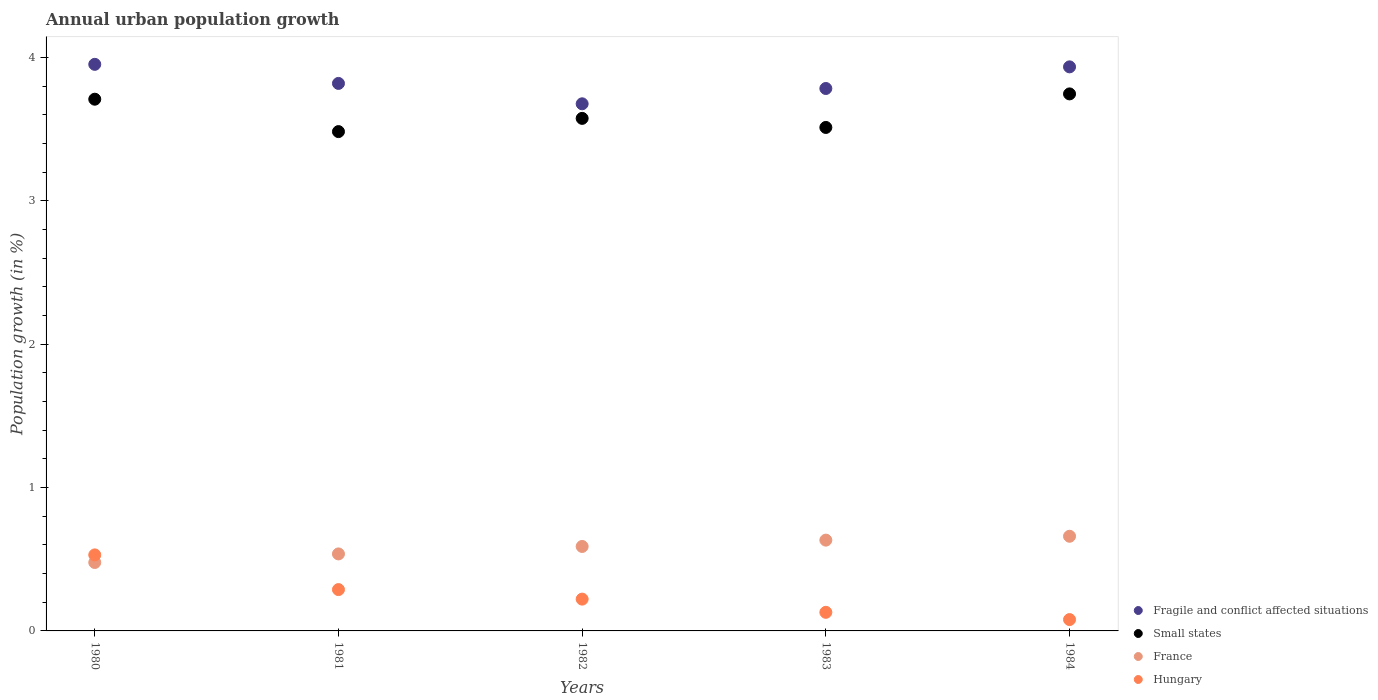How many different coloured dotlines are there?
Provide a short and direct response. 4. Is the number of dotlines equal to the number of legend labels?
Make the answer very short. Yes. What is the percentage of urban population growth in France in 1984?
Offer a terse response. 0.66. Across all years, what is the maximum percentage of urban population growth in Hungary?
Keep it short and to the point. 0.53. Across all years, what is the minimum percentage of urban population growth in Hungary?
Offer a very short reply. 0.08. In which year was the percentage of urban population growth in Hungary minimum?
Your response must be concise. 1984. What is the total percentage of urban population growth in Hungary in the graph?
Offer a very short reply. 1.25. What is the difference between the percentage of urban population growth in Fragile and conflict affected situations in 1981 and that in 1983?
Your answer should be very brief. 0.04. What is the difference between the percentage of urban population growth in France in 1984 and the percentage of urban population growth in Small states in 1982?
Make the answer very short. -2.92. What is the average percentage of urban population growth in Hungary per year?
Your response must be concise. 0.25. In the year 1981, what is the difference between the percentage of urban population growth in France and percentage of urban population growth in Small states?
Give a very brief answer. -2.95. What is the ratio of the percentage of urban population growth in Small states in 1980 to that in 1983?
Keep it short and to the point. 1.06. Is the difference between the percentage of urban population growth in France in 1980 and 1983 greater than the difference between the percentage of urban population growth in Small states in 1980 and 1983?
Your response must be concise. No. What is the difference between the highest and the second highest percentage of urban population growth in Small states?
Ensure brevity in your answer.  0.04. What is the difference between the highest and the lowest percentage of urban population growth in Fragile and conflict affected situations?
Give a very brief answer. 0.28. In how many years, is the percentage of urban population growth in France greater than the average percentage of urban population growth in France taken over all years?
Provide a succinct answer. 3. Is the sum of the percentage of urban population growth in Fragile and conflict affected situations in 1980 and 1984 greater than the maximum percentage of urban population growth in Small states across all years?
Your answer should be very brief. Yes. Does the percentage of urban population growth in France monotonically increase over the years?
Offer a very short reply. Yes. Is the percentage of urban population growth in Fragile and conflict affected situations strictly less than the percentage of urban population growth in France over the years?
Provide a succinct answer. No. How many dotlines are there?
Your response must be concise. 4. How many years are there in the graph?
Keep it short and to the point. 5. What is the difference between two consecutive major ticks on the Y-axis?
Offer a terse response. 1. Does the graph contain any zero values?
Your answer should be compact. No. How many legend labels are there?
Ensure brevity in your answer.  4. What is the title of the graph?
Ensure brevity in your answer.  Annual urban population growth. Does "Lower middle income" appear as one of the legend labels in the graph?
Keep it short and to the point. No. What is the label or title of the X-axis?
Offer a very short reply. Years. What is the label or title of the Y-axis?
Give a very brief answer. Population growth (in %). What is the Population growth (in %) of Fragile and conflict affected situations in 1980?
Provide a succinct answer. 3.95. What is the Population growth (in %) in Small states in 1980?
Your answer should be compact. 3.71. What is the Population growth (in %) in France in 1980?
Provide a short and direct response. 0.48. What is the Population growth (in %) in Hungary in 1980?
Your response must be concise. 0.53. What is the Population growth (in %) in Fragile and conflict affected situations in 1981?
Offer a very short reply. 3.82. What is the Population growth (in %) in Small states in 1981?
Offer a very short reply. 3.48. What is the Population growth (in %) of France in 1981?
Give a very brief answer. 0.54. What is the Population growth (in %) in Hungary in 1981?
Make the answer very short. 0.29. What is the Population growth (in %) in Fragile and conflict affected situations in 1982?
Keep it short and to the point. 3.68. What is the Population growth (in %) of Small states in 1982?
Your answer should be very brief. 3.58. What is the Population growth (in %) in France in 1982?
Offer a very short reply. 0.59. What is the Population growth (in %) of Hungary in 1982?
Offer a terse response. 0.22. What is the Population growth (in %) in Fragile and conflict affected situations in 1983?
Make the answer very short. 3.78. What is the Population growth (in %) of Small states in 1983?
Provide a short and direct response. 3.51. What is the Population growth (in %) of France in 1983?
Make the answer very short. 0.63. What is the Population growth (in %) in Hungary in 1983?
Provide a succinct answer. 0.13. What is the Population growth (in %) of Fragile and conflict affected situations in 1984?
Offer a terse response. 3.94. What is the Population growth (in %) of Small states in 1984?
Your response must be concise. 3.75. What is the Population growth (in %) in France in 1984?
Offer a very short reply. 0.66. What is the Population growth (in %) in Hungary in 1984?
Your answer should be very brief. 0.08. Across all years, what is the maximum Population growth (in %) in Fragile and conflict affected situations?
Your answer should be very brief. 3.95. Across all years, what is the maximum Population growth (in %) of Small states?
Your answer should be compact. 3.75. Across all years, what is the maximum Population growth (in %) in France?
Provide a short and direct response. 0.66. Across all years, what is the maximum Population growth (in %) in Hungary?
Provide a succinct answer. 0.53. Across all years, what is the minimum Population growth (in %) in Fragile and conflict affected situations?
Your answer should be compact. 3.68. Across all years, what is the minimum Population growth (in %) of Small states?
Offer a terse response. 3.48. Across all years, what is the minimum Population growth (in %) of France?
Ensure brevity in your answer.  0.48. Across all years, what is the minimum Population growth (in %) in Hungary?
Provide a succinct answer. 0.08. What is the total Population growth (in %) in Fragile and conflict affected situations in the graph?
Your answer should be very brief. 19.17. What is the total Population growth (in %) of Small states in the graph?
Offer a very short reply. 18.03. What is the total Population growth (in %) of France in the graph?
Offer a terse response. 2.9. What is the total Population growth (in %) of Hungary in the graph?
Your answer should be very brief. 1.25. What is the difference between the Population growth (in %) in Fragile and conflict affected situations in 1980 and that in 1981?
Ensure brevity in your answer.  0.13. What is the difference between the Population growth (in %) in Small states in 1980 and that in 1981?
Offer a terse response. 0.23. What is the difference between the Population growth (in %) of France in 1980 and that in 1981?
Provide a succinct answer. -0.06. What is the difference between the Population growth (in %) in Hungary in 1980 and that in 1981?
Your answer should be compact. 0.24. What is the difference between the Population growth (in %) of Fragile and conflict affected situations in 1980 and that in 1982?
Offer a terse response. 0.28. What is the difference between the Population growth (in %) in Small states in 1980 and that in 1982?
Ensure brevity in your answer.  0.13. What is the difference between the Population growth (in %) in France in 1980 and that in 1982?
Your response must be concise. -0.11. What is the difference between the Population growth (in %) in Hungary in 1980 and that in 1982?
Your answer should be very brief. 0.31. What is the difference between the Population growth (in %) in Fragile and conflict affected situations in 1980 and that in 1983?
Offer a very short reply. 0.17. What is the difference between the Population growth (in %) of Small states in 1980 and that in 1983?
Your answer should be compact. 0.2. What is the difference between the Population growth (in %) of France in 1980 and that in 1983?
Ensure brevity in your answer.  -0.16. What is the difference between the Population growth (in %) in Hungary in 1980 and that in 1983?
Offer a very short reply. 0.4. What is the difference between the Population growth (in %) in Fragile and conflict affected situations in 1980 and that in 1984?
Provide a succinct answer. 0.02. What is the difference between the Population growth (in %) in Small states in 1980 and that in 1984?
Provide a succinct answer. -0.04. What is the difference between the Population growth (in %) in France in 1980 and that in 1984?
Your answer should be compact. -0.18. What is the difference between the Population growth (in %) in Hungary in 1980 and that in 1984?
Offer a very short reply. 0.45. What is the difference between the Population growth (in %) in Fragile and conflict affected situations in 1981 and that in 1982?
Your answer should be compact. 0.14. What is the difference between the Population growth (in %) of Small states in 1981 and that in 1982?
Your response must be concise. -0.09. What is the difference between the Population growth (in %) of France in 1981 and that in 1982?
Make the answer very short. -0.05. What is the difference between the Population growth (in %) in Hungary in 1981 and that in 1982?
Make the answer very short. 0.07. What is the difference between the Population growth (in %) of Fragile and conflict affected situations in 1981 and that in 1983?
Provide a succinct answer. 0.04. What is the difference between the Population growth (in %) of Small states in 1981 and that in 1983?
Offer a terse response. -0.03. What is the difference between the Population growth (in %) in France in 1981 and that in 1983?
Your response must be concise. -0.1. What is the difference between the Population growth (in %) of Hungary in 1981 and that in 1983?
Ensure brevity in your answer.  0.16. What is the difference between the Population growth (in %) in Fragile and conflict affected situations in 1981 and that in 1984?
Make the answer very short. -0.12. What is the difference between the Population growth (in %) of Small states in 1981 and that in 1984?
Offer a terse response. -0.26. What is the difference between the Population growth (in %) of France in 1981 and that in 1984?
Give a very brief answer. -0.12. What is the difference between the Population growth (in %) of Hungary in 1981 and that in 1984?
Keep it short and to the point. 0.21. What is the difference between the Population growth (in %) in Fragile and conflict affected situations in 1982 and that in 1983?
Give a very brief answer. -0.11. What is the difference between the Population growth (in %) in Small states in 1982 and that in 1983?
Ensure brevity in your answer.  0.06. What is the difference between the Population growth (in %) in France in 1982 and that in 1983?
Your answer should be very brief. -0.04. What is the difference between the Population growth (in %) in Hungary in 1982 and that in 1983?
Ensure brevity in your answer.  0.09. What is the difference between the Population growth (in %) of Fragile and conflict affected situations in 1982 and that in 1984?
Make the answer very short. -0.26. What is the difference between the Population growth (in %) of Small states in 1982 and that in 1984?
Your answer should be compact. -0.17. What is the difference between the Population growth (in %) in France in 1982 and that in 1984?
Make the answer very short. -0.07. What is the difference between the Population growth (in %) in Hungary in 1982 and that in 1984?
Your answer should be compact. 0.14. What is the difference between the Population growth (in %) of Fragile and conflict affected situations in 1983 and that in 1984?
Ensure brevity in your answer.  -0.15. What is the difference between the Population growth (in %) of Small states in 1983 and that in 1984?
Your answer should be very brief. -0.23. What is the difference between the Population growth (in %) in France in 1983 and that in 1984?
Provide a succinct answer. -0.03. What is the difference between the Population growth (in %) of Hungary in 1983 and that in 1984?
Ensure brevity in your answer.  0.05. What is the difference between the Population growth (in %) of Fragile and conflict affected situations in 1980 and the Population growth (in %) of Small states in 1981?
Keep it short and to the point. 0.47. What is the difference between the Population growth (in %) in Fragile and conflict affected situations in 1980 and the Population growth (in %) in France in 1981?
Offer a terse response. 3.42. What is the difference between the Population growth (in %) of Fragile and conflict affected situations in 1980 and the Population growth (in %) of Hungary in 1981?
Give a very brief answer. 3.66. What is the difference between the Population growth (in %) in Small states in 1980 and the Population growth (in %) in France in 1981?
Ensure brevity in your answer.  3.17. What is the difference between the Population growth (in %) of Small states in 1980 and the Population growth (in %) of Hungary in 1981?
Keep it short and to the point. 3.42. What is the difference between the Population growth (in %) in France in 1980 and the Population growth (in %) in Hungary in 1981?
Your answer should be compact. 0.19. What is the difference between the Population growth (in %) in Fragile and conflict affected situations in 1980 and the Population growth (in %) in Small states in 1982?
Provide a short and direct response. 0.38. What is the difference between the Population growth (in %) in Fragile and conflict affected situations in 1980 and the Population growth (in %) in France in 1982?
Your response must be concise. 3.36. What is the difference between the Population growth (in %) in Fragile and conflict affected situations in 1980 and the Population growth (in %) in Hungary in 1982?
Your response must be concise. 3.73. What is the difference between the Population growth (in %) in Small states in 1980 and the Population growth (in %) in France in 1982?
Provide a succinct answer. 3.12. What is the difference between the Population growth (in %) in Small states in 1980 and the Population growth (in %) in Hungary in 1982?
Keep it short and to the point. 3.49. What is the difference between the Population growth (in %) of France in 1980 and the Population growth (in %) of Hungary in 1982?
Offer a terse response. 0.26. What is the difference between the Population growth (in %) in Fragile and conflict affected situations in 1980 and the Population growth (in %) in Small states in 1983?
Keep it short and to the point. 0.44. What is the difference between the Population growth (in %) in Fragile and conflict affected situations in 1980 and the Population growth (in %) in France in 1983?
Keep it short and to the point. 3.32. What is the difference between the Population growth (in %) in Fragile and conflict affected situations in 1980 and the Population growth (in %) in Hungary in 1983?
Offer a very short reply. 3.82. What is the difference between the Population growth (in %) of Small states in 1980 and the Population growth (in %) of France in 1983?
Your response must be concise. 3.08. What is the difference between the Population growth (in %) of Small states in 1980 and the Population growth (in %) of Hungary in 1983?
Your answer should be compact. 3.58. What is the difference between the Population growth (in %) of France in 1980 and the Population growth (in %) of Hungary in 1983?
Your answer should be very brief. 0.35. What is the difference between the Population growth (in %) in Fragile and conflict affected situations in 1980 and the Population growth (in %) in Small states in 1984?
Provide a short and direct response. 0.21. What is the difference between the Population growth (in %) in Fragile and conflict affected situations in 1980 and the Population growth (in %) in France in 1984?
Keep it short and to the point. 3.29. What is the difference between the Population growth (in %) in Fragile and conflict affected situations in 1980 and the Population growth (in %) in Hungary in 1984?
Your response must be concise. 3.87. What is the difference between the Population growth (in %) of Small states in 1980 and the Population growth (in %) of France in 1984?
Offer a very short reply. 3.05. What is the difference between the Population growth (in %) of Small states in 1980 and the Population growth (in %) of Hungary in 1984?
Make the answer very short. 3.63. What is the difference between the Population growth (in %) of France in 1980 and the Population growth (in %) of Hungary in 1984?
Give a very brief answer. 0.4. What is the difference between the Population growth (in %) of Fragile and conflict affected situations in 1981 and the Population growth (in %) of Small states in 1982?
Offer a terse response. 0.24. What is the difference between the Population growth (in %) in Fragile and conflict affected situations in 1981 and the Population growth (in %) in France in 1982?
Ensure brevity in your answer.  3.23. What is the difference between the Population growth (in %) in Fragile and conflict affected situations in 1981 and the Population growth (in %) in Hungary in 1982?
Offer a very short reply. 3.6. What is the difference between the Population growth (in %) of Small states in 1981 and the Population growth (in %) of France in 1982?
Make the answer very short. 2.89. What is the difference between the Population growth (in %) in Small states in 1981 and the Population growth (in %) in Hungary in 1982?
Keep it short and to the point. 3.26. What is the difference between the Population growth (in %) of France in 1981 and the Population growth (in %) of Hungary in 1982?
Your answer should be very brief. 0.32. What is the difference between the Population growth (in %) in Fragile and conflict affected situations in 1981 and the Population growth (in %) in Small states in 1983?
Your answer should be compact. 0.31. What is the difference between the Population growth (in %) of Fragile and conflict affected situations in 1981 and the Population growth (in %) of France in 1983?
Your response must be concise. 3.19. What is the difference between the Population growth (in %) of Fragile and conflict affected situations in 1981 and the Population growth (in %) of Hungary in 1983?
Ensure brevity in your answer.  3.69. What is the difference between the Population growth (in %) in Small states in 1981 and the Population growth (in %) in France in 1983?
Make the answer very short. 2.85. What is the difference between the Population growth (in %) in Small states in 1981 and the Population growth (in %) in Hungary in 1983?
Offer a terse response. 3.35. What is the difference between the Population growth (in %) in France in 1981 and the Population growth (in %) in Hungary in 1983?
Your answer should be very brief. 0.41. What is the difference between the Population growth (in %) of Fragile and conflict affected situations in 1981 and the Population growth (in %) of Small states in 1984?
Keep it short and to the point. 0.07. What is the difference between the Population growth (in %) of Fragile and conflict affected situations in 1981 and the Population growth (in %) of France in 1984?
Offer a very short reply. 3.16. What is the difference between the Population growth (in %) of Fragile and conflict affected situations in 1981 and the Population growth (in %) of Hungary in 1984?
Make the answer very short. 3.74. What is the difference between the Population growth (in %) in Small states in 1981 and the Population growth (in %) in France in 1984?
Provide a succinct answer. 2.82. What is the difference between the Population growth (in %) in Small states in 1981 and the Population growth (in %) in Hungary in 1984?
Keep it short and to the point. 3.4. What is the difference between the Population growth (in %) in France in 1981 and the Population growth (in %) in Hungary in 1984?
Your response must be concise. 0.46. What is the difference between the Population growth (in %) of Fragile and conflict affected situations in 1982 and the Population growth (in %) of Small states in 1983?
Your answer should be compact. 0.16. What is the difference between the Population growth (in %) in Fragile and conflict affected situations in 1982 and the Population growth (in %) in France in 1983?
Your response must be concise. 3.04. What is the difference between the Population growth (in %) of Fragile and conflict affected situations in 1982 and the Population growth (in %) of Hungary in 1983?
Keep it short and to the point. 3.55. What is the difference between the Population growth (in %) of Small states in 1982 and the Population growth (in %) of France in 1983?
Offer a very short reply. 2.94. What is the difference between the Population growth (in %) of Small states in 1982 and the Population growth (in %) of Hungary in 1983?
Provide a short and direct response. 3.45. What is the difference between the Population growth (in %) in France in 1982 and the Population growth (in %) in Hungary in 1983?
Keep it short and to the point. 0.46. What is the difference between the Population growth (in %) of Fragile and conflict affected situations in 1982 and the Population growth (in %) of Small states in 1984?
Your answer should be compact. -0.07. What is the difference between the Population growth (in %) in Fragile and conflict affected situations in 1982 and the Population growth (in %) in France in 1984?
Your answer should be very brief. 3.02. What is the difference between the Population growth (in %) in Fragile and conflict affected situations in 1982 and the Population growth (in %) in Hungary in 1984?
Give a very brief answer. 3.6. What is the difference between the Population growth (in %) of Small states in 1982 and the Population growth (in %) of France in 1984?
Ensure brevity in your answer.  2.92. What is the difference between the Population growth (in %) in Small states in 1982 and the Population growth (in %) in Hungary in 1984?
Keep it short and to the point. 3.5. What is the difference between the Population growth (in %) of France in 1982 and the Population growth (in %) of Hungary in 1984?
Make the answer very short. 0.51. What is the difference between the Population growth (in %) in Fragile and conflict affected situations in 1983 and the Population growth (in %) in Small states in 1984?
Your answer should be compact. 0.04. What is the difference between the Population growth (in %) of Fragile and conflict affected situations in 1983 and the Population growth (in %) of France in 1984?
Make the answer very short. 3.12. What is the difference between the Population growth (in %) of Fragile and conflict affected situations in 1983 and the Population growth (in %) of Hungary in 1984?
Offer a terse response. 3.71. What is the difference between the Population growth (in %) in Small states in 1983 and the Population growth (in %) in France in 1984?
Your answer should be compact. 2.85. What is the difference between the Population growth (in %) of Small states in 1983 and the Population growth (in %) of Hungary in 1984?
Your response must be concise. 3.43. What is the difference between the Population growth (in %) of France in 1983 and the Population growth (in %) of Hungary in 1984?
Your answer should be compact. 0.55. What is the average Population growth (in %) of Fragile and conflict affected situations per year?
Keep it short and to the point. 3.83. What is the average Population growth (in %) of Small states per year?
Provide a succinct answer. 3.61. What is the average Population growth (in %) in France per year?
Provide a short and direct response. 0.58. What is the average Population growth (in %) of Hungary per year?
Provide a short and direct response. 0.25. In the year 1980, what is the difference between the Population growth (in %) in Fragile and conflict affected situations and Population growth (in %) in Small states?
Offer a terse response. 0.24. In the year 1980, what is the difference between the Population growth (in %) of Fragile and conflict affected situations and Population growth (in %) of France?
Your response must be concise. 3.48. In the year 1980, what is the difference between the Population growth (in %) in Fragile and conflict affected situations and Population growth (in %) in Hungary?
Make the answer very short. 3.42. In the year 1980, what is the difference between the Population growth (in %) of Small states and Population growth (in %) of France?
Offer a terse response. 3.23. In the year 1980, what is the difference between the Population growth (in %) of Small states and Population growth (in %) of Hungary?
Keep it short and to the point. 3.18. In the year 1980, what is the difference between the Population growth (in %) in France and Population growth (in %) in Hungary?
Give a very brief answer. -0.05. In the year 1981, what is the difference between the Population growth (in %) of Fragile and conflict affected situations and Population growth (in %) of Small states?
Offer a very short reply. 0.34. In the year 1981, what is the difference between the Population growth (in %) of Fragile and conflict affected situations and Population growth (in %) of France?
Make the answer very short. 3.28. In the year 1981, what is the difference between the Population growth (in %) of Fragile and conflict affected situations and Population growth (in %) of Hungary?
Ensure brevity in your answer.  3.53. In the year 1981, what is the difference between the Population growth (in %) of Small states and Population growth (in %) of France?
Your response must be concise. 2.95. In the year 1981, what is the difference between the Population growth (in %) of Small states and Population growth (in %) of Hungary?
Give a very brief answer. 3.2. In the year 1981, what is the difference between the Population growth (in %) of France and Population growth (in %) of Hungary?
Give a very brief answer. 0.25. In the year 1982, what is the difference between the Population growth (in %) of Fragile and conflict affected situations and Population growth (in %) of Small states?
Provide a succinct answer. 0.1. In the year 1982, what is the difference between the Population growth (in %) in Fragile and conflict affected situations and Population growth (in %) in France?
Provide a short and direct response. 3.09. In the year 1982, what is the difference between the Population growth (in %) of Fragile and conflict affected situations and Population growth (in %) of Hungary?
Provide a succinct answer. 3.46. In the year 1982, what is the difference between the Population growth (in %) in Small states and Population growth (in %) in France?
Your answer should be compact. 2.99. In the year 1982, what is the difference between the Population growth (in %) of Small states and Population growth (in %) of Hungary?
Provide a short and direct response. 3.35. In the year 1982, what is the difference between the Population growth (in %) of France and Population growth (in %) of Hungary?
Your answer should be very brief. 0.37. In the year 1983, what is the difference between the Population growth (in %) in Fragile and conflict affected situations and Population growth (in %) in Small states?
Make the answer very short. 0.27. In the year 1983, what is the difference between the Population growth (in %) of Fragile and conflict affected situations and Population growth (in %) of France?
Your answer should be compact. 3.15. In the year 1983, what is the difference between the Population growth (in %) of Fragile and conflict affected situations and Population growth (in %) of Hungary?
Make the answer very short. 3.65. In the year 1983, what is the difference between the Population growth (in %) in Small states and Population growth (in %) in France?
Give a very brief answer. 2.88. In the year 1983, what is the difference between the Population growth (in %) in Small states and Population growth (in %) in Hungary?
Provide a succinct answer. 3.38. In the year 1983, what is the difference between the Population growth (in %) in France and Population growth (in %) in Hungary?
Your answer should be compact. 0.5. In the year 1984, what is the difference between the Population growth (in %) of Fragile and conflict affected situations and Population growth (in %) of Small states?
Give a very brief answer. 0.19. In the year 1984, what is the difference between the Population growth (in %) in Fragile and conflict affected situations and Population growth (in %) in France?
Give a very brief answer. 3.27. In the year 1984, what is the difference between the Population growth (in %) in Fragile and conflict affected situations and Population growth (in %) in Hungary?
Provide a succinct answer. 3.86. In the year 1984, what is the difference between the Population growth (in %) in Small states and Population growth (in %) in France?
Keep it short and to the point. 3.09. In the year 1984, what is the difference between the Population growth (in %) in Small states and Population growth (in %) in Hungary?
Your answer should be very brief. 3.67. In the year 1984, what is the difference between the Population growth (in %) in France and Population growth (in %) in Hungary?
Make the answer very short. 0.58. What is the ratio of the Population growth (in %) of Fragile and conflict affected situations in 1980 to that in 1981?
Make the answer very short. 1.03. What is the ratio of the Population growth (in %) in Small states in 1980 to that in 1981?
Your answer should be very brief. 1.06. What is the ratio of the Population growth (in %) in France in 1980 to that in 1981?
Offer a very short reply. 0.89. What is the ratio of the Population growth (in %) of Hungary in 1980 to that in 1981?
Provide a succinct answer. 1.84. What is the ratio of the Population growth (in %) in Fragile and conflict affected situations in 1980 to that in 1982?
Your answer should be very brief. 1.07. What is the ratio of the Population growth (in %) in Small states in 1980 to that in 1982?
Offer a very short reply. 1.04. What is the ratio of the Population growth (in %) of France in 1980 to that in 1982?
Provide a succinct answer. 0.81. What is the ratio of the Population growth (in %) in Hungary in 1980 to that in 1982?
Provide a short and direct response. 2.39. What is the ratio of the Population growth (in %) of Fragile and conflict affected situations in 1980 to that in 1983?
Your answer should be compact. 1.04. What is the ratio of the Population growth (in %) in Small states in 1980 to that in 1983?
Your response must be concise. 1.06. What is the ratio of the Population growth (in %) of France in 1980 to that in 1983?
Offer a very short reply. 0.75. What is the ratio of the Population growth (in %) of Hungary in 1980 to that in 1983?
Offer a terse response. 4.09. What is the ratio of the Population growth (in %) in Fragile and conflict affected situations in 1980 to that in 1984?
Offer a terse response. 1. What is the ratio of the Population growth (in %) in France in 1980 to that in 1984?
Keep it short and to the point. 0.72. What is the ratio of the Population growth (in %) in Hungary in 1980 to that in 1984?
Offer a very short reply. 6.7. What is the ratio of the Population growth (in %) in Fragile and conflict affected situations in 1981 to that in 1982?
Offer a terse response. 1.04. What is the ratio of the Population growth (in %) in Small states in 1981 to that in 1982?
Provide a succinct answer. 0.97. What is the ratio of the Population growth (in %) in France in 1981 to that in 1982?
Give a very brief answer. 0.91. What is the ratio of the Population growth (in %) of Hungary in 1981 to that in 1982?
Provide a succinct answer. 1.3. What is the ratio of the Population growth (in %) of Fragile and conflict affected situations in 1981 to that in 1983?
Provide a succinct answer. 1.01. What is the ratio of the Population growth (in %) of France in 1981 to that in 1983?
Make the answer very short. 0.85. What is the ratio of the Population growth (in %) of Hungary in 1981 to that in 1983?
Your answer should be compact. 2.22. What is the ratio of the Population growth (in %) of Fragile and conflict affected situations in 1981 to that in 1984?
Offer a very short reply. 0.97. What is the ratio of the Population growth (in %) in Small states in 1981 to that in 1984?
Offer a very short reply. 0.93. What is the ratio of the Population growth (in %) in France in 1981 to that in 1984?
Your answer should be very brief. 0.81. What is the ratio of the Population growth (in %) of Hungary in 1981 to that in 1984?
Offer a very short reply. 3.64. What is the ratio of the Population growth (in %) in Fragile and conflict affected situations in 1982 to that in 1983?
Your response must be concise. 0.97. What is the ratio of the Population growth (in %) of Small states in 1982 to that in 1983?
Provide a short and direct response. 1.02. What is the ratio of the Population growth (in %) of France in 1982 to that in 1983?
Your answer should be compact. 0.93. What is the ratio of the Population growth (in %) of Hungary in 1982 to that in 1983?
Give a very brief answer. 1.71. What is the ratio of the Population growth (in %) in Fragile and conflict affected situations in 1982 to that in 1984?
Keep it short and to the point. 0.93. What is the ratio of the Population growth (in %) of Small states in 1982 to that in 1984?
Make the answer very short. 0.95. What is the ratio of the Population growth (in %) in France in 1982 to that in 1984?
Make the answer very short. 0.89. What is the ratio of the Population growth (in %) in Hungary in 1982 to that in 1984?
Give a very brief answer. 2.8. What is the ratio of the Population growth (in %) of Fragile and conflict affected situations in 1983 to that in 1984?
Your answer should be very brief. 0.96. What is the ratio of the Population growth (in %) in France in 1983 to that in 1984?
Provide a short and direct response. 0.96. What is the ratio of the Population growth (in %) in Hungary in 1983 to that in 1984?
Make the answer very short. 1.64. What is the difference between the highest and the second highest Population growth (in %) in Fragile and conflict affected situations?
Provide a short and direct response. 0.02. What is the difference between the highest and the second highest Population growth (in %) of Small states?
Provide a succinct answer. 0.04. What is the difference between the highest and the second highest Population growth (in %) in France?
Ensure brevity in your answer.  0.03. What is the difference between the highest and the second highest Population growth (in %) of Hungary?
Your answer should be compact. 0.24. What is the difference between the highest and the lowest Population growth (in %) in Fragile and conflict affected situations?
Offer a terse response. 0.28. What is the difference between the highest and the lowest Population growth (in %) in Small states?
Give a very brief answer. 0.26. What is the difference between the highest and the lowest Population growth (in %) in France?
Your response must be concise. 0.18. What is the difference between the highest and the lowest Population growth (in %) of Hungary?
Give a very brief answer. 0.45. 